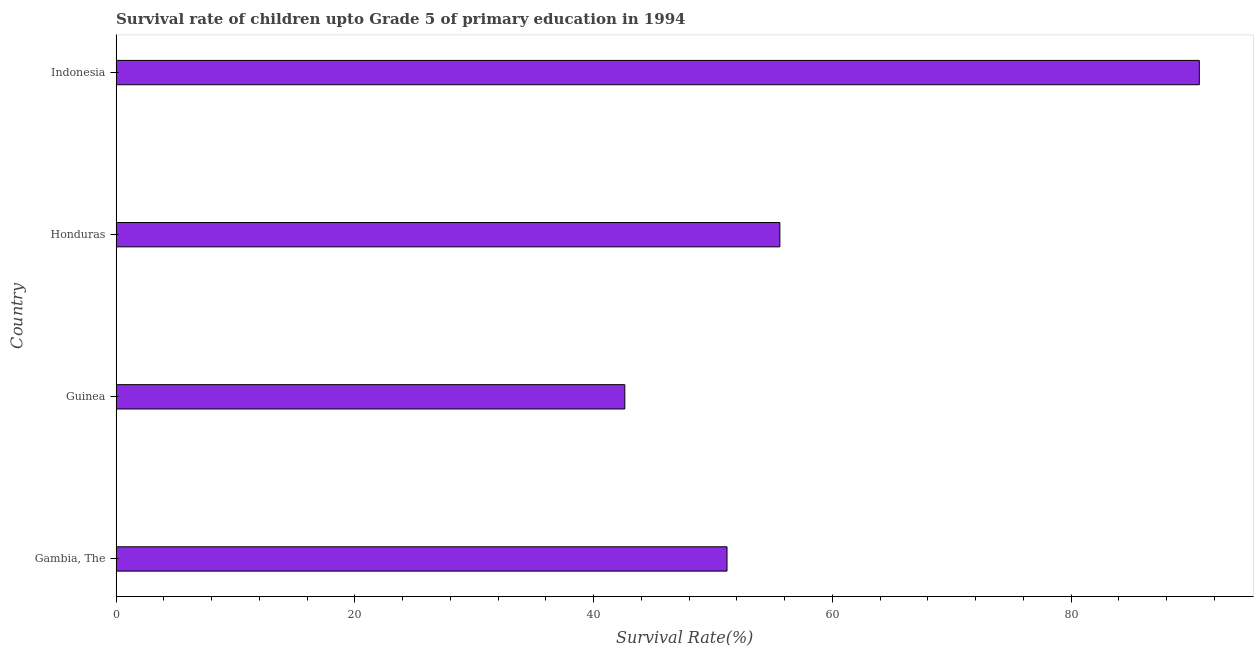Does the graph contain grids?
Offer a terse response. No. What is the title of the graph?
Ensure brevity in your answer.  Survival rate of children upto Grade 5 of primary education in 1994 . What is the label or title of the X-axis?
Give a very brief answer. Survival Rate(%). What is the survival rate in Honduras?
Offer a terse response. 55.61. Across all countries, what is the maximum survival rate?
Offer a terse response. 90.75. Across all countries, what is the minimum survival rate?
Offer a terse response. 42.62. In which country was the survival rate minimum?
Make the answer very short. Guinea. What is the sum of the survival rate?
Your response must be concise. 240.16. What is the difference between the survival rate in Gambia, The and Indonesia?
Ensure brevity in your answer.  -39.57. What is the average survival rate per country?
Offer a very short reply. 60.04. What is the median survival rate?
Offer a very short reply. 53.39. In how many countries, is the survival rate greater than 84 %?
Make the answer very short. 1. Is the survival rate in Honduras less than that in Indonesia?
Your answer should be very brief. Yes. Is the difference between the survival rate in Honduras and Indonesia greater than the difference between any two countries?
Provide a short and direct response. No. What is the difference between the highest and the second highest survival rate?
Provide a short and direct response. 35.14. What is the difference between the highest and the lowest survival rate?
Your answer should be compact. 48.13. In how many countries, is the survival rate greater than the average survival rate taken over all countries?
Provide a succinct answer. 1. How many bars are there?
Offer a terse response. 4. How many countries are there in the graph?
Your answer should be very brief. 4. What is the difference between two consecutive major ticks on the X-axis?
Offer a terse response. 20. What is the Survival Rate(%) of Gambia, The?
Provide a short and direct response. 51.18. What is the Survival Rate(%) in Guinea?
Your answer should be very brief. 42.62. What is the Survival Rate(%) in Honduras?
Your answer should be compact. 55.61. What is the Survival Rate(%) in Indonesia?
Make the answer very short. 90.75. What is the difference between the Survival Rate(%) in Gambia, The and Guinea?
Keep it short and to the point. 8.56. What is the difference between the Survival Rate(%) in Gambia, The and Honduras?
Give a very brief answer. -4.43. What is the difference between the Survival Rate(%) in Gambia, The and Indonesia?
Your response must be concise. -39.57. What is the difference between the Survival Rate(%) in Guinea and Honduras?
Offer a very short reply. -12.99. What is the difference between the Survival Rate(%) in Guinea and Indonesia?
Keep it short and to the point. -48.13. What is the difference between the Survival Rate(%) in Honduras and Indonesia?
Offer a very short reply. -35.14. What is the ratio of the Survival Rate(%) in Gambia, The to that in Guinea?
Make the answer very short. 1.2. What is the ratio of the Survival Rate(%) in Gambia, The to that in Honduras?
Keep it short and to the point. 0.92. What is the ratio of the Survival Rate(%) in Gambia, The to that in Indonesia?
Offer a terse response. 0.56. What is the ratio of the Survival Rate(%) in Guinea to that in Honduras?
Make the answer very short. 0.77. What is the ratio of the Survival Rate(%) in Guinea to that in Indonesia?
Provide a short and direct response. 0.47. What is the ratio of the Survival Rate(%) in Honduras to that in Indonesia?
Your answer should be compact. 0.61. 